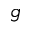<formula> <loc_0><loc_0><loc_500><loc_500>g</formula> 